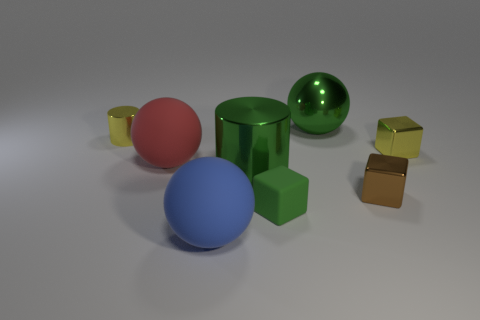There is a tiny yellow thing that is on the right side of the metallic ball right of the big blue matte ball; what is its shape?
Offer a terse response. Cube. How many other things are the same shape as the brown thing?
Keep it short and to the point. 2. Are there any things behind the yellow metal cube?
Ensure brevity in your answer.  Yes. The shiny ball has what color?
Provide a short and direct response. Green. Is the color of the metal sphere the same as the metallic cylinder in front of the tiny yellow shiny cylinder?
Your answer should be very brief. Yes. Are there any yellow blocks of the same size as the red matte object?
Keep it short and to the point. No. What size is the metallic cylinder that is the same color as the big metal ball?
Provide a succinct answer. Large. There is a tiny yellow thing on the left side of the yellow metal cube; what is it made of?
Provide a short and direct response. Metal. Are there the same number of rubber balls in front of the large shiny sphere and large green cylinders in front of the small green rubber thing?
Ensure brevity in your answer.  No. There is a shiny cylinder that is in front of the tiny yellow metal block; is it the same size as the ball behind the big red sphere?
Your answer should be very brief. Yes. 